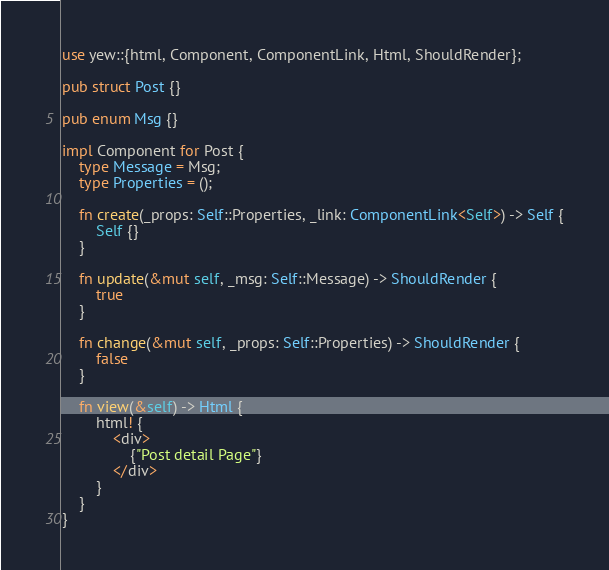<code> <loc_0><loc_0><loc_500><loc_500><_Rust_>use yew::{html, Component, ComponentLink, Html, ShouldRender};

pub struct Post {}

pub enum Msg {}

impl Component for Post {
    type Message = Msg;
    type Properties = ();

    fn create(_props: Self::Properties, _link: ComponentLink<Self>) -> Self {
        Self {}
    }

    fn update(&mut self, _msg: Self::Message) -> ShouldRender {
        true
    }

    fn change(&mut self, _props: Self::Properties) -> ShouldRender {
        false
    }

    fn view(&self) -> Html {
        html! {
            <div>
                {"Post detail Page"}
            </div>
        }
    }
}
</code> 